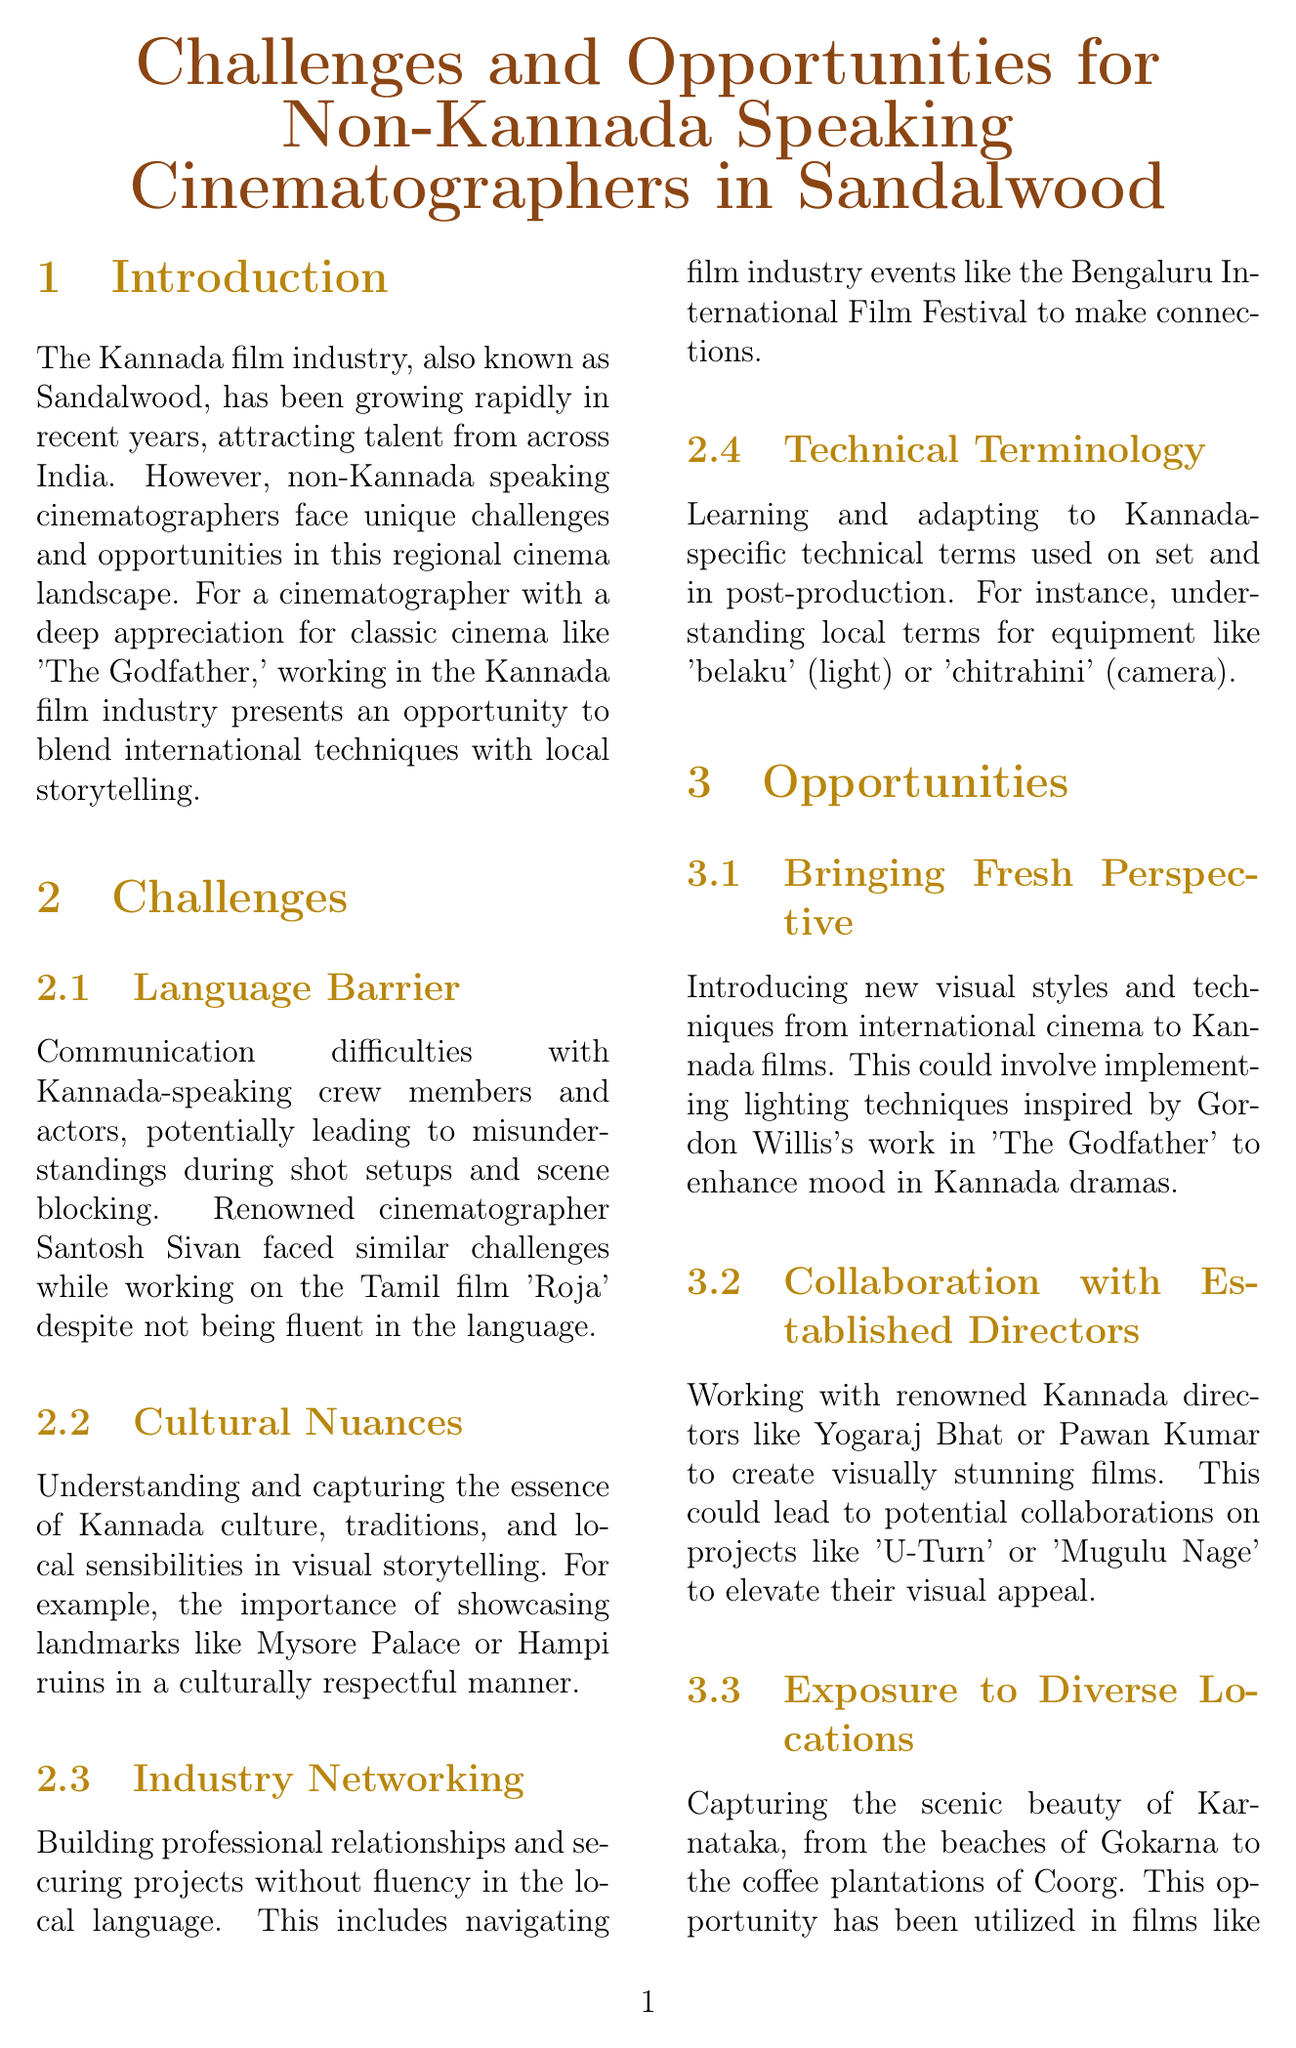what is the Kannada film industry also known as? The document refers to the Kannada film industry as Sandalwood.
Answer: Sandalwood who is a renowned cinematographer mentioned in discussing language barriers? The document provides an example of Santosh Sivan facing language barriers while working.
Answer: Santosh Sivan which cinematographer has a success story in Kannada blockbusters? The document mentions Ashok Cashyap as a non-Kannada speaking cinematographer successful in the industry.
Answer: Ashok Cashyap what is a potential opportunity for non-Kannada speaking cinematographers? The document highlights the opportunity of bringing new visual styles and techniques to Kannada films.
Answer: Bringing Fresh Perspective name one film mentioned that showcases Karnataka's scenic beauty. The document refers to 'Ulidavaru Kandanthe' as a film that showcases the scenic beauty of Karnataka.
Answer: Ulidavaru Kandanthe what industry event is suggested for networking? The document recommends attending the Bengaluru International Film Festival for networking opportunities.
Answer: Bengaluru International Film Festival which organization can cinematographers collaborate with for local talent? The document suggests partnering with the Karnataka Chalanachitra Academy for collaboration with local talent.
Answer: Karnataka Chalanachitra Academy what advanced technology is the Kannada film industry increasingly adopting? The document mentions the use of ARRI Alexa cameras as an example of advanced technology being adopted.
Answer: ARRI Alexa cameras 